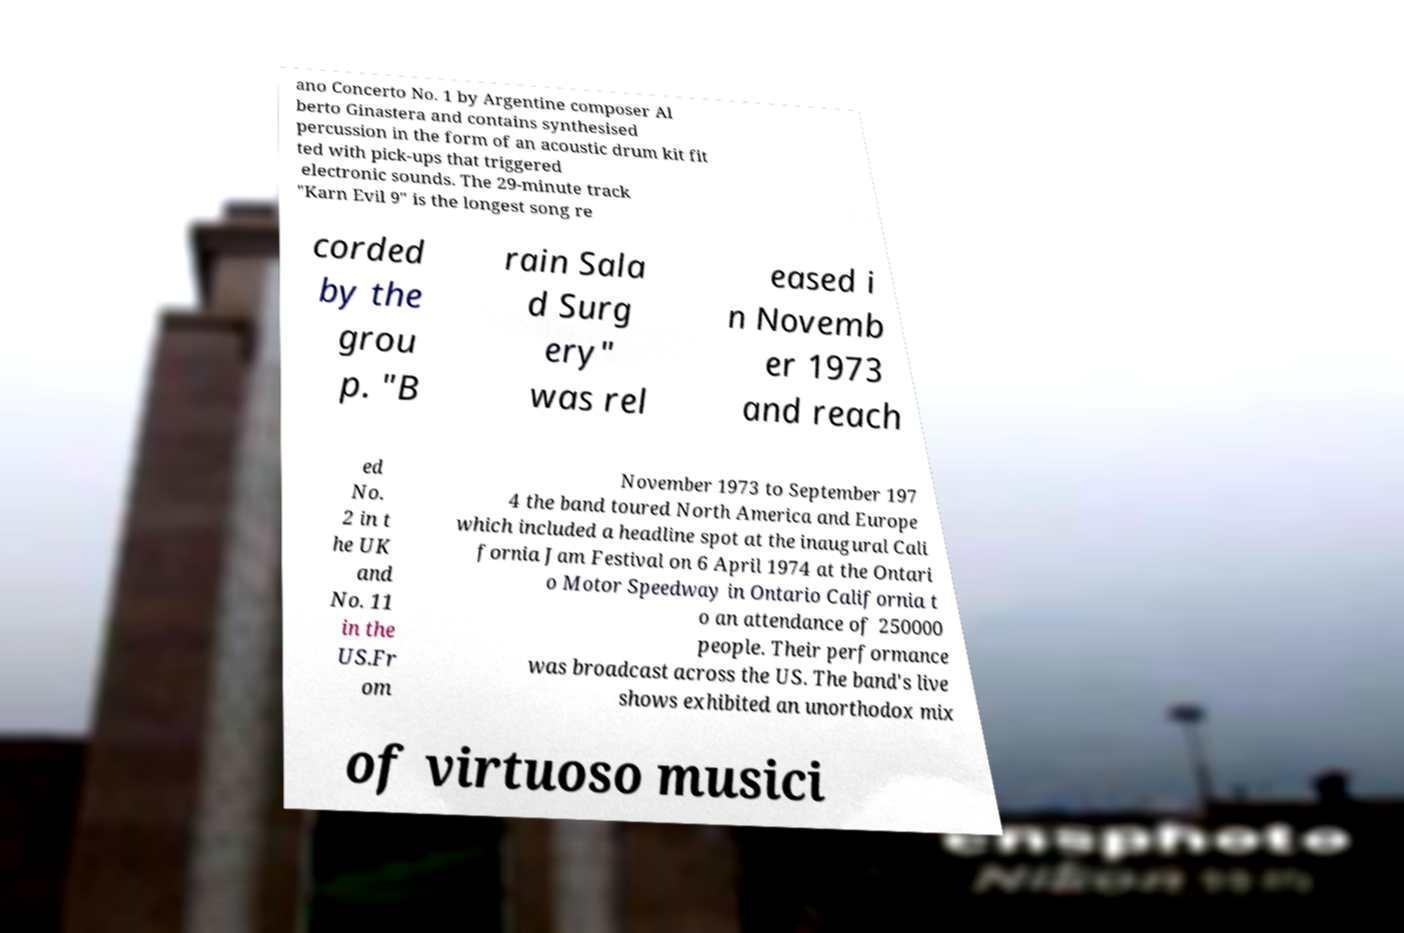Can you accurately transcribe the text from the provided image for me? ano Concerto No. 1 by Argentine composer Al berto Ginastera and contains synthesised percussion in the form of an acoustic drum kit fit ted with pick-ups that triggered electronic sounds. The 29-minute track "Karn Evil 9" is the longest song re corded by the grou p. "B rain Sala d Surg ery" was rel eased i n Novemb er 1973 and reach ed No. 2 in t he UK and No. 11 in the US.Fr om November 1973 to September 197 4 the band toured North America and Europe which included a headline spot at the inaugural Cali fornia Jam Festival on 6 April 1974 at the Ontari o Motor Speedway in Ontario California t o an attendance of 250000 people. Their performance was broadcast across the US. The band's live shows exhibited an unorthodox mix of virtuoso musici 